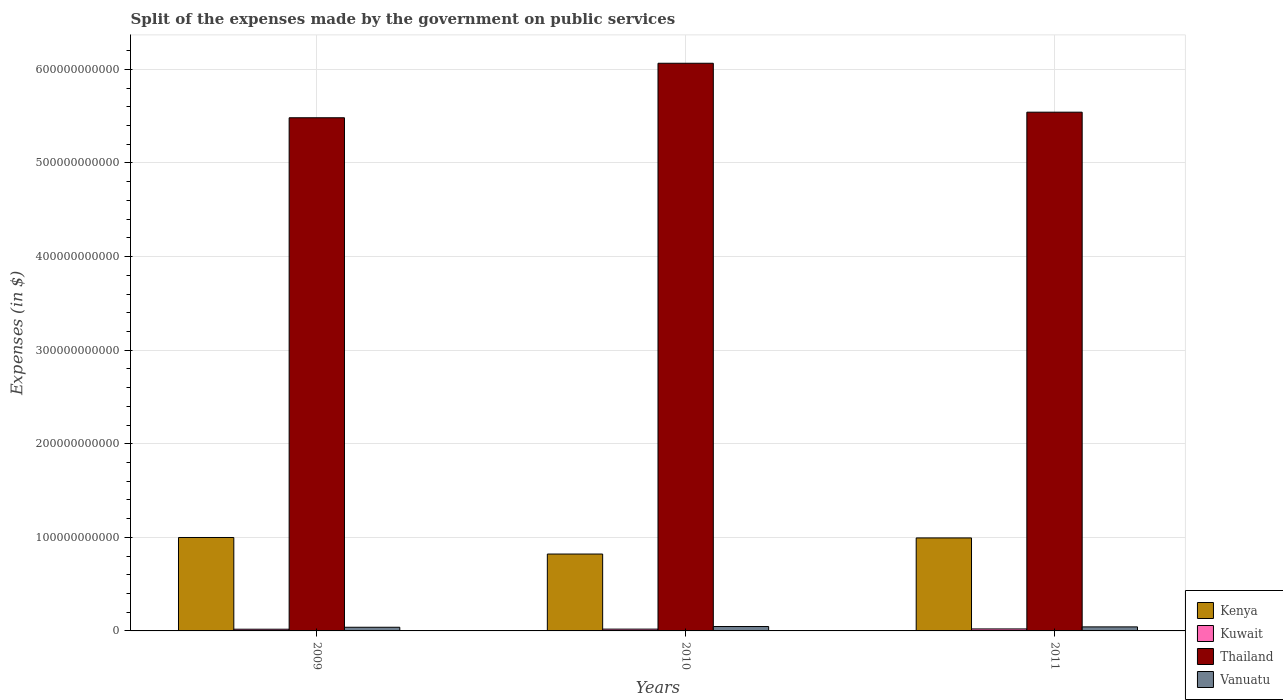How many different coloured bars are there?
Your answer should be compact. 4. Are the number of bars per tick equal to the number of legend labels?
Make the answer very short. Yes. How many bars are there on the 1st tick from the right?
Provide a short and direct response. 4. What is the expenses made by the government on public services in Thailand in 2011?
Your answer should be compact. 5.54e+11. Across all years, what is the maximum expenses made by the government on public services in Thailand?
Make the answer very short. 6.07e+11. Across all years, what is the minimum expenses made by the government on public services in Kuwait?
Provide a succinct answer. 1.82e+09. In which year was the expenses made by the government on public services in Kenya maximum?
Your answer should be very brief. 2009. What is the total expenses made by the government on public services in Kuwait in the graph?
Keep it short and to the point. 5.87e+09. What is the difference between the expenses made by the government on public services in Kenya in 2009 and that in 2010?
Offer a terse response. 1.77e+1. What is the difference between the expenses made by the government on public services in Kuwait in 2011 and the expenses made by the government on public services in Vanuatu in 2009?
Offer a terse response. -1.79e+09. What is the average expenses made by the government on public services in Kuwait per year?
Offer a terse response. 1.96e+09. In the year 2009, what is the difference between the expenses made by the government on public services in Kuwait and expenses made by the government on public services in Vanuatu?
Your answer should be very brief. -2.10e+09. What is the ratio of the expenses made by the government on public services in Kuwait in 2009 to that in 2010?
Provide a succinct answer. 0.95. Is the expenses made by the government on public services in Kuwait in 2010 less than that in 2011?
Provide a short and direct response. Yes. What is the difference between the highest and the second highest expenses made by the government on public services in Kenya?
Your answer should be compact. 4.78e+08. What is the difference between the highest and the lowest expenses made by the government on public services in Vanuatu?
Give a very brief answer. 7.73e+08. Is the sum of the expenses made by the government on public services in Kuwait in 2009 and 2010 greater than the maximum expenses made by the government on public services in Thailand across all years?
Give a very brief answer. No. What does the 1st bar from the left in 2011 represents?
Offer a very short reply. Kenya. What does the 3rd bar from the right in 2010 represents?
Provide a short and direct response. Kuwait. Is it the case that in every year, the sum of the expenses made by the government on public services in Kenya and expenses made by the government on public services in Thailand is greater than the expenses made by the government on public services in Vanuatu?
Make the answer very short. Yes. Are all the bars in the graph horizontal?
Provide a short and direct response. No. How many years are there in the graph?
Make the answer very short. 3. What is the difference between two consecutive major ticks on the Y-axis?
Your response must be concise. 1.00e+11. Are the values on the major ticks of Y-axis written in scientific E-notation?
Offer a terse response. No. Does the graph contain grids?
Your response must be concise. Yes. Where does the legend appear in the graph?
Provide a short and direct response. Bottom right. How many legend labels are there?
Ensure brevity in your answer.  4. What is the title of the graph?
Provide a succinct answer. Split of the expenses made by the government on public services. Does "Canada" appear as one of the legend labels in the graph?
Make the answer very short. No. What is the label or title of the Y-axis?
Give a very brief answer. Expenses (in $). What is the Expenses (in $) of Kenya in 2009?
Your response must be concise. 9.98e+1. What is the Expenses (in $) in Kuwait in 2009?
Provide a succinct answer. 1.82e+09. What is the Expenses (in $) of Thailand in 2009?
Your answer should be very brief. 5.48e+11. What is the Expenses (in $) in Vanuatu in 2009?
Keep it short and to the point. 3.92e+09. What is the Expenses (in $) in Kenya in 2010?
Your answer should be very brief. 8.22e+1. What is the Expenses (in $) in Kuwait in 2010?
Provide a short and direct response. 1.92e+09. What is the Expenses (in $) of Thailand in 2010?
Make the answer very short. 6.07e+11. What is the Expenses (in $) in Vanuatu in 2010?
Your answer should be very brief. 4.69e+09. What is the Expenses (in $) in Kenya in 2011?
Provide a succinct answer. 9.94e+1. What is the Expenses (in $) in Kuwait in 2011?
Make the answer very short. 2.13e+09. What is the Expenses (in $) in Thailand in 2011?
Provide a succinct answer. 5.54e+11. What is the Expenses (in $) of Vanuatu in 2011?
Provide a short and direct response. 4.31e+09. Across all years, what is the maximum Expenses (in $) of Kenya?
Your answer should be compact. 9.98e+1. Across all years, what is the maximum Expenses (in $) of Kuwait?
Your answer should be compact. 2.13e+09. Across all years, what is the maximum Expenses (in $) of Thailand?
Offer a terse response. 6.07e+11. Across all years, what is the maximum Expenses (in $) in Vanuatu?
Ensure brevity in your answer.  4.69e+09. Across all years, what is the minimum Expenses (in $) in Kenya?
Offer a terse response. 8.22e+1. Across all years, what is the minimum Expenses (in $) of Kuwait?
Offer a very short reply. 1.82e+09. Across all years, what is the minimum Expenses (in $) in Thailand?
Keep it short and to the point. 5.48e+11. Across all years, what is the minimum Expenses (in $) in Vanuatu?
Your answer should be compact. 3.92e+09. What is the total Expenses (in $) of Kenya in the graph?
Your response must be concise. 2.81e+11. What is the total Expenses (in $) of Kuwait in the graph?
Your response must be concise. 5.87e+09. What is the total Expenses (in $) in Thailand in the graph?
Provide a succinct answer. 1.71e+12. What is the total Expenses (in $) of Vanuatu in the graph?
Make the answer very short. 1.29e+1. What is the difference between the Expenses (in $) in Kenya in 2009 and that in 2010?
Your answer should be compact. 1.77e+1. What is the difference between the Expenses (in $) of Kuwait in 2009 and that in 2010?
Offer a very short reply. -9.80e+07. What is the difference between the Expenses (in $) of Thailand in 2009 and that in 2010?
Give a very brief answer. -5.82e+1. What is the difference between the Expenses (in $) of Vanuatu in 2009 and that in 2010?
Keep it short and to the point. -7.73e+08. What is the difference between the Expenses (in $) in Kenya in 2009 and that in 2011?
Ensure brevity in your answer.  4.78e+08. What is the difference between the Expenses (in $) in Kuwait in 2009 and that in 2011?
Your answer should be very brief. -3.07e+08. What is the difference between the Expenses (in $) of Thailand in 2009 and that in 2011?
Keep it short and to the point. -5.96e+09. What is the difference between the Expenses (in $) of Vanuatu in 2009 and that in 2011?
Offer a terse response. -3.89e+08. What is the difference between the Expenses (in $) in Kenya in 2010 and that in 2011?
Give a very brief answer. -1.72e+1. What is the difference between the Expenses (in $) in Kuwait in 2010 and that in 2011?
Give a very brief answer. -2.09e+08. What is the difference between the Expenses (in $) in Thailand in 2010 and that in 2011?
Ensure brevity in your answer.  5.23e+1. What is the difference between the Expenses (in $) in Vanuatu in 2010 and that in 2011?
Make the answer very short. 3.84e+08. What is the difference between the Expenses (in $) in Kenya in 2009 and the Expenses (in $) in Kuwait in 2010?
Your response must be concise. 9.79e+1. What is the difference between the Expenses (in $) of Kenya in 2009 and the Expenses (in $) of Thailand in 2010?
Provide a succinct answer. -5.07e+11. What is the difference between the Expenses (in $) of Kenya in 2009 and the Expenses (in $) of Vanuatu in 2010?
Your answer should be very brief. 9.51e+1. What is the difference between the Expenses (in $) of Kuwait in 2009 and the Expenses (in $) of Thailand in 2010?
Keep it short and to the point. -6.05e+11. What is the difference between the Expenses (in $) in Kuwait in 2009 and the Expenses (in $) in Vanuatu in 2010?
Ensure brevity in your answer.  -2.87e+09. What is the difference between the Expenses (in $) of Thailand in 2009 and the Expenses (in $) of Vanuatu in 2010?
Offer a very short reply. 5.44e+11. What is the difference between the Expenses (in $) in Kenya in 2009 and the Expenses (in $) in Kuwait in 2011?
Provide a short and direct response. 9.77e+1. What is the difference between the Expenses (in $) of Kenya in 2009 and the Expenses (in $) of Thailand in 2011?
Keep it short and to the point. -4.54e+11. What is the difference between the Expenses (in $) in Kenya in 2009 and the Expenses (in $) in Vanuatu in 2011?
Offer a terse response. 9.55e+1. What is the difference between the Expenses (in $) of Kuwait in 2009 and the Expenses (in $) of Thailand in 2011?
Make the answer very short. -5.52e+11. What is the difference between the Expenses (in $) of Kuwait in 2009 and the Expenses (in $) of Vanuatu in 2011?
Your answer should be very brief. -2.49e+09. What is the difference between the Expenses (in $) of Thailand in 2009 and the Expenses (in $) of Vanuatu in 2011?
Your answer should be very brief. 5.44e+11. What is the difference between the Expenses (in $) in Kenya in 2010 and the Expenses (in $) in Kuwait in 2011?
Provide a short and direct response. 8.00e+1. What is the difference between the Expenses (in $) in Kenya in 2010 and the Expenses (in $) in Thailand in 2011?
Ensure brevity in your answer.  -4.72e+11. What is the difference between the Expenses (in $) of Kenya in 2010 and the Expenses (in $) of Vanuatu in 2011?
Your answer should be compact. 7.78e+1. What is the difference between the Expenses (in $) in Kuwait in 2010 and the Expenses (in $) in Thailand in 2011?
Offer a very short reply. -5.52e+11. What is the difference between the Expenses (in $) of Kuwait in 2010 and the Expenses (in $) of Vanuatu in 2011?
Give a very brief answer. -2.39e+09. What is the difference between the Expenses (in $) of Thailand in 2010 and the Expenses (in $) of Vanuatu in 2011?
Keep it short and to the point. 6.02e+11. What is the average Expenses (in $) of Kenya per year?
Offer a terse response. 9.38e+1. What is the average Expenses (in $) of Kuwait per year?
Your answer should be very brief. 1.96e+09. What is the average Expenses (in $) of Thailand per year?
Ensure brevity in your answer.  5.70e+11. What is the average Expenses (in $) of Vanuatu per year?
Your answer should be compact. 4.31e+09. In the year 2009, what is the difference between the Expenses (in $) of Kenya and Expenses (in $) of Kuwait?
Give a very brief answer. 9.80e+1. In the year 2009, what is the difference between the Expenses (in $) of Kenya and Expenses (in $) of Thailand?
Ensure brevity in your answer.  -4.49e+11. In the year 2009, what is the difference between the Expenses (in $) in Kenya and Expenses (in $) in Vanuatu?
Offer a terse response. 9.59e+1. In the year 2009, what is the difference between the Expenses (in $) in Kuwait and Expenses (in $) in Thailand?
Your answer should be compact. -5.47e+11. In the year 2009, what is the difference between the Expenses (in $) in Kuwait and Expenses (in $) in Vanuatu?
Your response must be concise. -2.10e+09. In the year 2009, what is the difference between the Expenses (in $) of Thailand and Expenses (in $) of Vanuatu?
Keep it short and to the point. 5.44e+11. In the year 2010, what is the difference between the Expenses (in $) in Kenya and Expenses (in $) in Kuwait?
Offer a terse response. 8.02e+1. In the year 2010, what is the difference between the Expenses (in $) in Kenya and Expenses (in $) in Thailand?
Offer a terse response. -5.24e+11. In the year 2010, what is the difference between the Expenses (in $) in Kenya and Expenses (in $) in Vanuatu?
Give a very brief answer. 7.75e+1. In the year 2010, what is the difference between the Expenses (in $) in Kuwait and Expenses (in $) in Thailand?
Give a very brief answer. -6.05e+11. In the year 2010, what is the difference between the Expenses (in $) of Kuwait and Expenses (in $) of Vanuatu?
Your answer should be very brief. -2.77e+09. In the year 2010, what is the difference between the Expenses (in $) of Thailand and Expenses (in $) of Vanuatu?
Ensure brevity in your answer.  6.02e+11. In the year 2011, what is the difference between the Expenses (in $) of Kenya and Expenses (in $) of Kuwait?
Offer a terse response. 9.72e+1. In the year 2011, what is the difference between the Expenses (in $) of Kenya and Expenses (in $) of Thailand?
Your response must be concise. -4.55e+11. In the year 2011, what is the difference between the Expenses (in $) of Kenya and Expenses (in $) of Vanuatu?
Keep it short and to the point. 9.51e+1. In the year 2011, what is the difference between the Expenses (in $) in Kuwait and Expenses (in $) in Thailand?
Your response must be concise. -5.52e+11. In the year 2011, what is the difference between the Expenses (in $) of Kuwait and Expenses (in $) of Vanuatu?
Offer a terse response. -2.18e+09. In the year 2011, what is the difference between the Expenses (in $) of Thailand and Expenses (in $) of Vanuatu?
Ensure brevity in your answer.  5.50e+11. What is the ratio of the Expenses (in $) of Kenya in 2009 to that in 2010?
Provide a succinct answer. 1.22. What is the ratio of the Expenses (in $) of Kuwait in 2009 to that in 2010?
Make the answer very short. 0.95. What is the ratio of the Expenses (in $) of Thailand in 2009 to that in 2010?
Offer a terse response. 0.9. What is the ratio of the Expenses (in $) of Vanuatu in 2009 to that in 2010?
Your answer should be compact. 0.84. What is the ratio of the Expenses (in $) in Kuwait in 2009 to that in 2011?
Your answer should be very brief. 0.86. What is the ratio of the Expenses (in $) of Vanuatu in 2009 to that in 2011?
Ensure brevity in your answer.  0.91. What is the ratio of the Expenses (in $) in Kenya in 2010 to that in 2011?
Give a very brief answer. 0.83. What is the ratio of the Expenses (in $) of Kuwait in 2010 to that in 2011?
Your answer should be very brief. 0.9. What is the ratio of the Expenses (in $) of Thailand in 2010 to that in 2011?
Ensure brevity in your answer.  1.09. What is the ratio of the Expenses (in $) of Vanuatu in 2010 to that in 2011?
Provide a short and direct response. 1.09. What is the difference between the highest and the second highest Expenses (in $) of Kenya?
Your answer should be very brief. 4.78e+08. What is the difference between the highest and the second highest Expenses (in $) in Kuwait?
Your answer should be very brief. 2.09e+08. What is the difference between the highest and the second highest Expenses (in $) in Thailand?
Provide a succinct answer. 5.23e+1. What is the difference between the highest and the second highest Expenses (in $) of Vanuatu?
Provide a short and direct response. 3.84e+08. What is the difference between the highest and the lowest Expenses (in $) of Kenya?
Provide a succinct answer. 1.77e+1. What is the difference between the highest and the lowest Expenses (in $) in Kuwait?
Make the answer very short. 3.07e+08. What is the difference between the highest and the lowest Expenses (in $) of Thailand?
Your answer should be compact. 5.82e+1. What is the difference between the highest and the lowest Expenses (in $) of Vanuatu?
Offer a very short reply. 7.73e+08. 